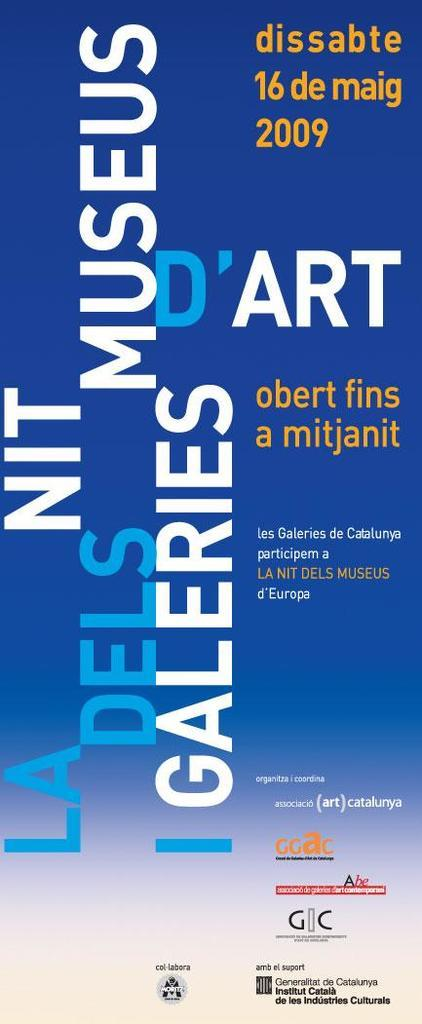Provide a one-sentence caption for the provided image. The poster advertises an art event that happened in May of 2009. 